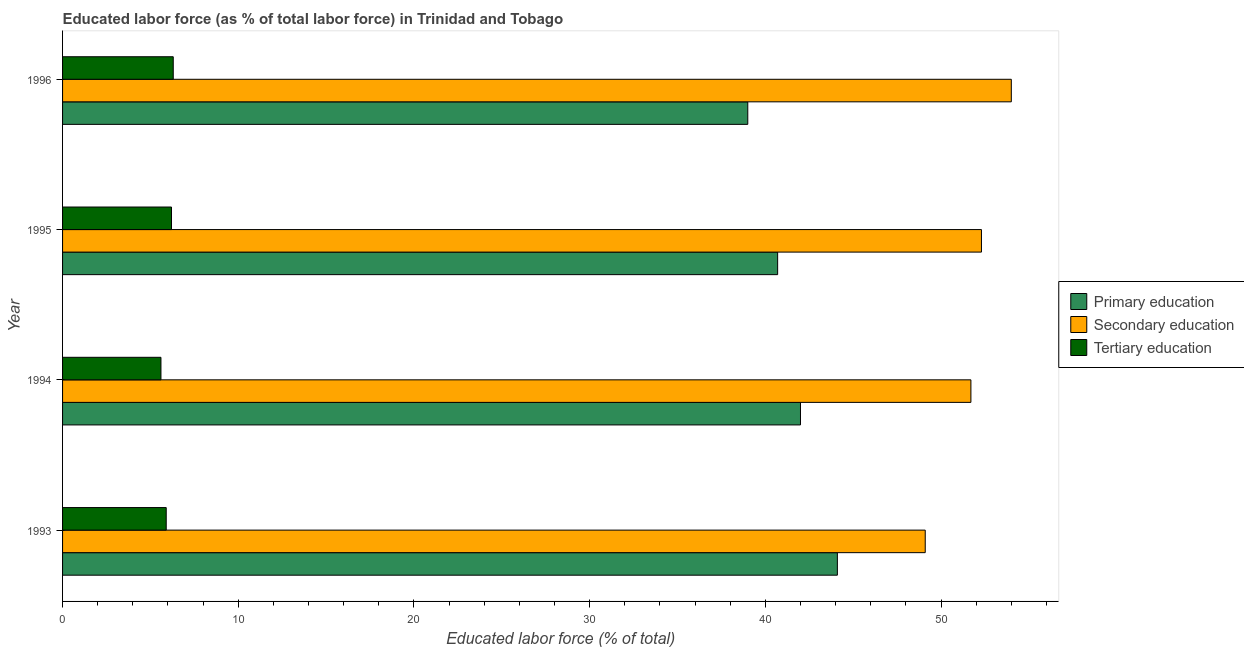How many different coloured bars are there?
Offer a very short reply. 3. How many groups of bars are there?
Keep it short and to the point. 4. How many bars are there on the 2nd tick from the top?
Offer a very short reply. 3. What is the label of the 1st group of bars from the top?
Ensure brevity in your answer.  1996. In how many cases, is the number of bars for a given year not equal to the number of legend labels?
Give a very brief answer. 0. What is the percentage of labor force who received primary education in 1996?
Your answer should be compact. 39. Across all years, what is the maximum percentage of labor force who received tertiary education?
Provide a short and direct response. 6.3. Across all years, what is the minimum percentage of labor force who received tertiary education?
Your answer should be compact. 5.6. In which year was the percentage of labor force who received primary education maximum?
Make the answer very short. 1993. What is the total percentage of labor force who received secondary education in the graph?
Ensure brevity in your answer.  207.1. What is the difference between the percentage of labor force who received primary education in 1993 and the percentage of labor force who received secondary education in 1994?
Offer a terse response. -7.6. What is the average percentage of labor force who received tertiary education per year?
Your response must be concise. 6. In the year 1994, what is the difference between the percentage of labor force who received tertiary education and percentage of labor force who received primary education?
Your answer should be compact. -36.4. What is the ratio of the percentage of labor force who received secondary education in 1993 to that in 1994?
Your response must be concise. 0.95. Is the percentage of labor force who received primary education in 1994 less than that in 1996?
Your response must be concise. No. What is the difference between the highest and the second highest percentage of labor force who received primary education?
Ensure brevity in your answer.  2.1. What is the difference between the highest and the lowest percentage of labor force who received secondary education?
Offer a very short reply. 4.9. What does the 1st bar from the top in 1993 represents?
Offer a very short reply. Tertiary education. What does the 2nd bar from the bottom in 1996 represents?
Give a very brief answer. Secondary education. Are all the bars in the graph horizontal?
Give a very brief answer. Yes. How many years are there in the graph?
Your answer should be compact. 4. Are the values on the major ticks of X-axis written in scientific E-notation?
Offer a terse response. No. What is the title of the graph?
Provide a short and direct response. Educated labor force (as % of total labor force) in Trinidad and Tobago. Does "Tertiary education" appear as one of the legend labels in the graph?
Provide a succinct answer. Yes. What is the label or title of the X-axis?
Offer a very short reply. Educated labor force (% of total). What is the Educated labor force (% of total) of Primary education in 1993?
Your answer should be compact. 44.1. What is the Educated labor force (% of total) of Secondary education in 1993?
Offer a very short reply. 49.1. What is the Educated labor force (% of total) of Tertiary education in 1993?
Ensure brevity in your answer.  5.9. What is the Educated labor force (% of total) of Primary education in 1994?
Give a very brief answer. 42. What is the Educated labor force (% of total) in Secondary education in 1994?
Your response must be concise. 51.7. What is the Educated labor force (% of total) in Tertiary education in 1994?
Keep it short and to the point. 5.6. What is the Educated labor force (% of total) of Primary education in 1995?
Offer a very short reply. 40.7. What is the Educated labor force (% of total) of Secondary education in 1995?
Give a very brief answer. 52.3. What is the Educated labor force (% of total) in Tertiary education in 1995?
Provide a succinct answer. 6.2. What is the Educated labor force (% of total) of Secondary education in 1996?
Your answer should be very brief. 54. What is the Educated labor force (% of total) in Tertiary education in 1996?
Your answer should be compact. 6.3. Across all years, what is the maximum Educated labor force (% of total) of Primary education?
Ensure brevity in your answer.  44.1. Across all years, what is the maximum Educated labor force (% of total) in Secondary education?
Ensure brevity in your answer.  54. Across all years, what is the maximum Educated labor force (% of total) in Tertiary education?
Provide a succinct answer. 6.3. Across all years, what is the minimum Educated labor force (% of total) of Primary education?
Give a very brief answer. 39. Across all years, what is the minimum Educated labor force (% of total) in Secondary education?
Your answer should be very brief. 49.1. Across all years, what is the minimum Educated labor force (% of total) of Tertiary education?
Your answer should be very brief. 5.6. What is the total Educated labor force (% of total) of Primary education in the graph?
Your answer should be compact. 165.8. What is the total Educated labor force (% of total) of Secondary education in the graph?
Offer a very short reply. 207.1. What is the total Educated labor force (% of total) of Tertiary education in the graph?
Your response must be concise. 24. What is the difference between the Educated labor force (% of total) in Primary education in 1993 and that in 1994?
Offer a very short reply. 2.1. What is the difference between the Educated labor force (% of total) of Primary education in 1993 and that in 1995?
Keep it short and to the point. 3.4. What is the difference between the Educated labor force (% of total) of Tertiary education in 1993 and that in 1995?
Give a very brief answer. -0.3. What is the difference between the Educated labor force (% of total) of Secondary education in 1993 and that in 1996?
Your response must be concise. -4.9. What is the difference between the Educated labor force (% of total) of Tertiary education in 1994 and that in 1995?
Your response must be concise. -0.6. What is the difference between the Educated labor force (% of total) in Primary education in 1994 and that in 1996?
Your answer should be very brief. 3. What is the difference between the Educated labor force (% of total) in Tertiary education in 1994 and that in 1996?
Make the answer very short. -0.7. What is the difference between the Educated labor force (% of total) in Primary education in 1993 and the Educated labor force (% of total) in Tertiary education in 1994?
Offer a very short reply. 38.5. What is the difference between the Educated labor force (% of total) in Secondary education in 1993 and the Educated labor force (% of total) in Tertiary education in 1994?
Give a very brief answer. 43.5. What is the difference between the Educated labor force (% of total) in Primary education in 1993 and the Educated labor force (% of total) in Secondary education in 1995?
Provide a short and direct response. -8.2. What is the difference between the Educated labor force (% of total) of Primary education in 1993 and the Educated labor force (% of total) of Tertiary education in 1995?
Provide a short and direct response. 37.9. What is the difference between the Educated labor force (% of total) of Secondary education in 1993 and the Educated labor force (% of total) of Tertiary education in 1995?
Offer a terse response. 42.9. What is the difference between the Educated labor force (% of total) of Primary education in 1993 and the Educated labor force (% of total) of Secondary education in 1996?
Your answer should be very brief. -9.9. What is the difference between the Educated labor force (% of total) of Primary education in 1993 and the Educated labor force (% of total) of Tertiary education in 1996?
Ensure brevity in your answer.  37.8. What is the difference between the Educated labor force (% of total) of Secondary education in 1993 and the Educated labor force (% of total) of Tertiary education in 1996?
Provide a succinct answer. 42.8. What is the difference between the Educated labor force (% of total) in Primary education in 1994 and the Educated labor force (% of total) in Secondary education in 1995?
Give a very brief answer. -10.3. What is the difference between the Educated labor force (% of total) of Primary education in 1994 and the Educated labor force (% of total) of Tertiary education in 1995?
Your answer should be compact. 35.8. What is the difference between the Educated labor force (% of total) in Secondary education in 1994 and the Educated labor force (% of total) in Tertiary education in 1995?
Make the answer very short. 45.5. What is the difference between the Educated labor force (% of total) in Primary education in 1994 and the Educated labor force (% of total) in Tertiary education in 1996?
Your answer should be compact. 35.7. What is the difference between the Educated labor force (% of total) in Secondary education in 1994 and the Educated labor force (% of total) in Tertiary education in 1996?
Keep it short and to the point. 45.4. What is the difference between the Educated labor force (% of total) in Primary education in 1995 and the Educated labor force (% of total) in Tertiary education in 1996?
Provide a succinct answer. 34.4. What is the average Educated labor force (% of total) of Primary education per year?
Provide a short and direct response. 41.45. What is the average Educated labor force (% of total) in Secondary education per year?
Ensure brevity in your answer.  51.77. What is the average Educated labor force (% of total) in Tertiary education per year?
Ensure brevity in your answer.  6. In the year 1993, what is the difference between the Educated labor force (% of total) in Primary education and Educated labor force (% of total) in Secondary education?
Offer a terse response. -5. In the year 1993, what is the difference between the Educated labor force (% of total) of Primary education and Educated labor force (% of total) of Tertiary education?
Your answer should be compact. 38.2. In the year 1993, what is the difference between the Educated labor force (% of total) in Secondary education and Educated labor force (% of total) in Tertiary education?
Keep it short and to the point. 43.2. In the year 1994, what is the difference between the Educated labor force (% of total) of Primary education and Educated labor force (% of total) of Secondary education?
Provide a short and direct response. -9.7. In the year 1994, what is the difference between the Educated labor force (% of total) in Primary education and Educated labor force (% of total) in Tertiary education?
Provide a succinct answer. 36.4. In the year 1994, what is the difference between the Educated labor force (% of total) of Secondary education and Educated labor force (% of total) of Tertiary education?
Keep it short and to the point. 46.1. In the year 1995, what is the difference between the Educated labor force (% of total) in Primary education and Educated labor force (% of total) in Secondary education?
Ensure brevity in your answer.  -11.6. In the year 1995, what is the difference between the Educated labor force (% of total) in Primary education and Educated labor force (% of total) in Tertiary education?
Your response must be concise. 34.5. In the year 1995, what is the difference between the Educated labor force (% of total) in Secondary education and Educated labor force (% of total) in Tertiary education?
Your answer should be compact. 46.1. In the year 1996, what is the difference between the Educated labor force (% of total) in Primary education and Educated labor force (% of total) in Secondary education?
Ensure brevity in your answer.  -15. In the year 1996, what is the difference between the Educated labor force (% of total) of Primary education and Educated labor force (% of total) of Tertiary education?
Offer a terse response. 32.7. In the year 1996, what is the difference between the Educated labor force (% of total) in Secondary education and Educated labor force (% of total) in Tertiary education?
Ensure brevity in your answer.  47.7. What is the ratio of the Educated labor force (% of total) of Secondary education in 1993 to that in 1994?
Give a very brief answer. 0.95. What is the ratio of the Educated labor force (% of total) in Tertiary education in 1993 to that in 1994?
Provide a short and direct response. 1.05. What is the ratio of the Educated labor force (% of total) of Primary education in 1993 to that in 1995?
Give a very brief answer. 1.08. What is the ratio of the Educated labor force (% of total) in Secondary education in 1993 to that in 1995?
Ensure brevity in your answer.  0.94. What is the ratio of the Educated labor force (% of total) of Tertiary education in 1993 to that in 1995?
Provide a succinct answer. 0.95. What is the ratio of the Educated labor force (% of total) of Primary education in 1993 to that in 1996?
Offer a very short reply. 1.13. What is the ratio of the Educated labor force (% of total) in Secondary education in 1993 to that in 1996?
Provide a short and direct response. 0.91. What is the ratio of the Educated labor force (% of total) in Tertiary education in 1993 to that in 1996?
Offer a terse response. 0.94. What is the ratio of the Educated labor force (% of total) of Primary education in 1994 to that in 1995?
Your answer should be very brief. 1.03. What is the ratio of the Educated labor force (% of total) in Tertiary education in 1994 to that in 1995?
Provide a succinct answer. 0.9. What is the ratio of the Educated labor force (% of total) in Secondary education in 1994 to that in 1996?
Your answer should be compact. 0.96. What is the ratio of the Educated labor force (% of total) of Tertiary education in 1994 to that in 1996?
Provide a short and direct response. 0.89. What is the ratio of the Educated labor force (% of total) in Primary education in 1995 to that in 1996?
Keep it short and to the point. 1.04. What is the ratio of the Educated labor force (% of total) in Secondary education in 1995 to that in 1996?
Offer a very short reply. 0.97. What is the ratio of the Educated labor force (% of total) in Tertiary education in 1995 to that in 1996?
Offer a very short reply. 0.98. What is the difference between the highest and the lowest Educated labor force (% of total) of Tertiary education?
Offer a terse response. 0.7. 